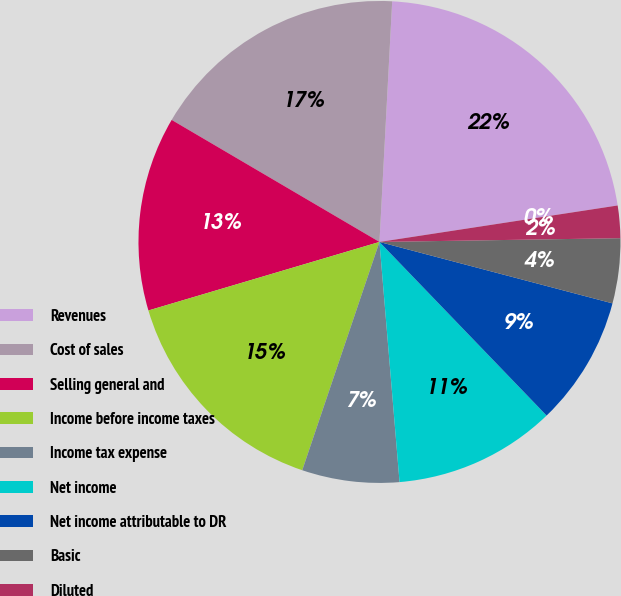Convert chart to OTSL. <chart><loc_0><loc_0><loc_500><loc_500><pie_chart><fcel>Revenues<fcel>Cost of sales<fcel>Selling general and<fcel>Income before income taxes<fcel>Income tax expense<fcel>Net income<fcel>Net income attributable to DR<fcel>Basic<fcel>Diluted<fcel>Cash dividends declared per<nl><fcel>21.74%<fcel>17.39%<fcel>13.04%<fcel>15.22%<fcel>6.52%<fcel>10.87%<fcel>8.7%<fcel>4.35%<fcel>2.17%<fcel>0.0%<nl></chart> 